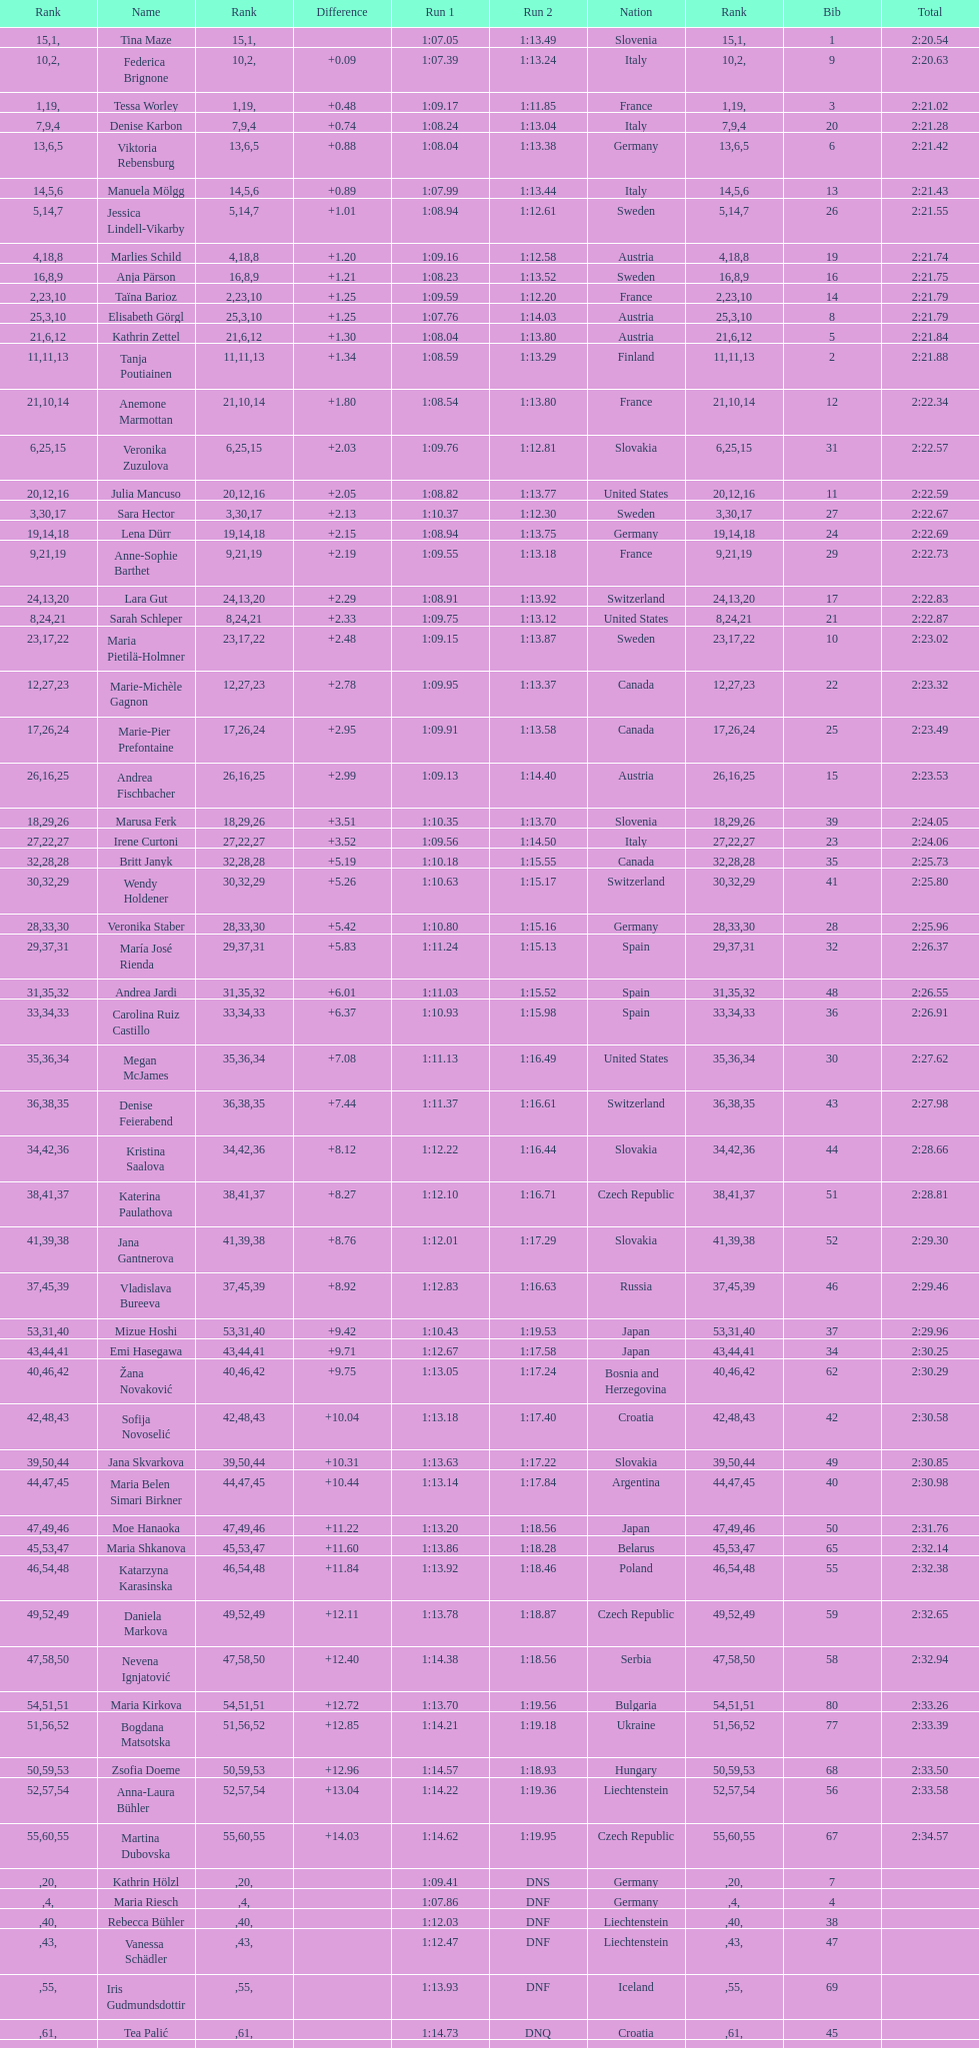What was the number of swedes in the top fifteen? 2. 